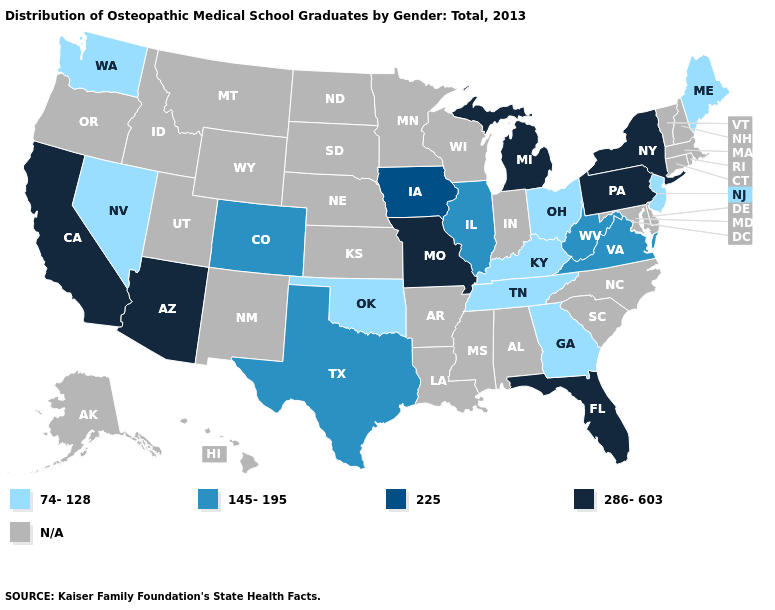Among the states that border Nebraska , does Iowa have the lowest value?
Concise answer only. No. What is the value of Kansas?
Quick response, please. N/A. What is the value of Pennsylvania?
Keep it brief. 286-603. Among the states that border Wisconsin , does Illinois have the highest value?
Write a very short answer. No. Does Oklahoma have the highest value in the USA?
Give a very brief answer. No. Name the states that have a value in the range N/A?
Keep it brief. Alabama, Alaska, Arkansas, Connecticut, Delaware, Hawaii, Idaho, Indiana, Kansas, Louisiana, Maryland, Massachusetts, Minnesota, Mississippi, Montana, Nebraska, New Hampshire, New Mexico, North Carolina, North Dakota, Oregon, Rhode Island, South Carolina, South Dakota, Utah, Vermont, Wisconsin, Wyoming. What is the lowest value in states that border Idaho?
Be succinct. 74-128. What is the highest value in states that border Indiana?
Write a very short answer. 286-603. What is the value of North Carolina?
Short answer required. N/A. What is the lowest value in the Northeast?
Quick response, please. 74-128. What is the value of Maryland?
Short answer required. N/A. What is the lowest value in the USA?
Keep it brief. 74-128. 